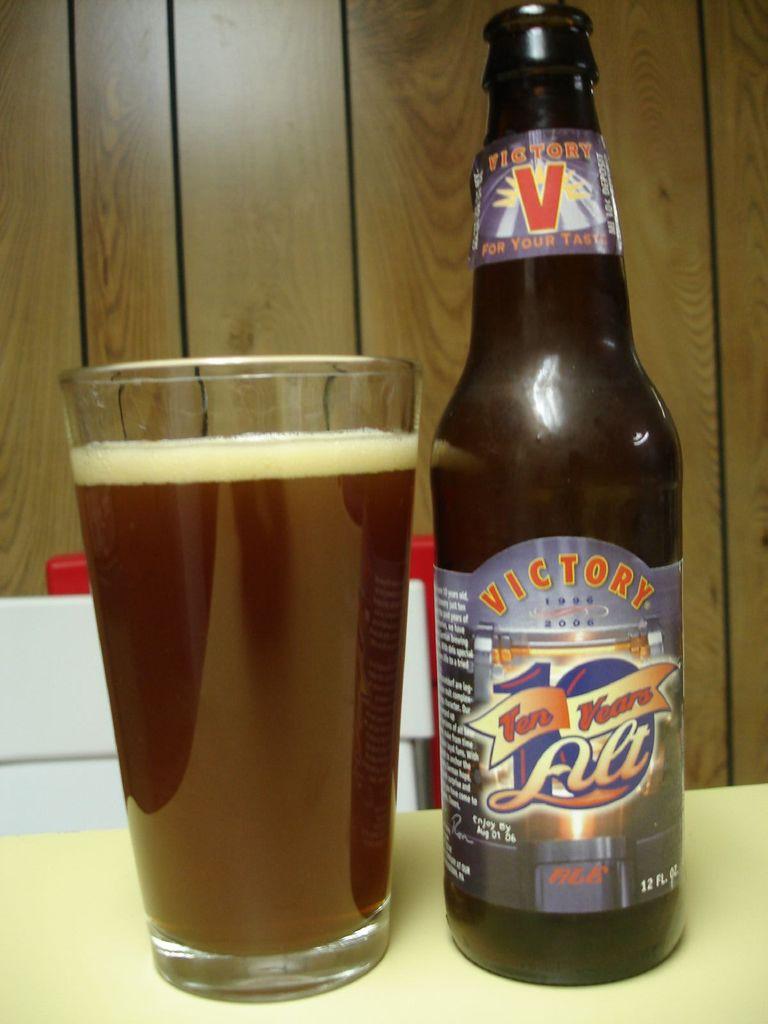V is for what brewery company?
Your answer should be compact. Victory. 